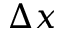<formula> <loc_0><loc_0><loc_500><loc_500>\Delta x</formula> 